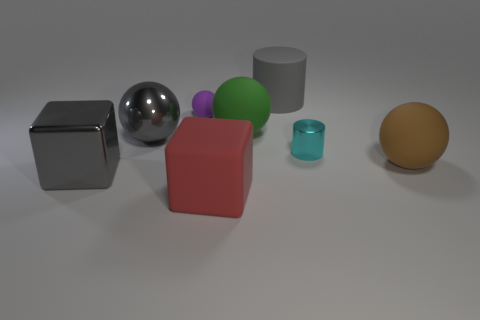Subtract 1 balls. How many balls are left? 3 Subtract all purple balls. How many balls are left? 3 Subtract all brown matte balls. How many balls are left? 3 Add 1 big metal spheres. How many objects exist? 9 Subtract all cylinders. How many objects are left? 6 Subtract all blue spheres. Subtract all blue cylinders. How many spheres are left? 4 Subtract all brown blocks. Subtract all tiny purple balls. How many objects are left? 7 Add 5 small matte spheres. How many small matte spheres are left? 6 Add 7 yellow metal blocks. How many yellow metal blocks exist? 7 Subtract 0 yellow balls. How many objects are left? 8 